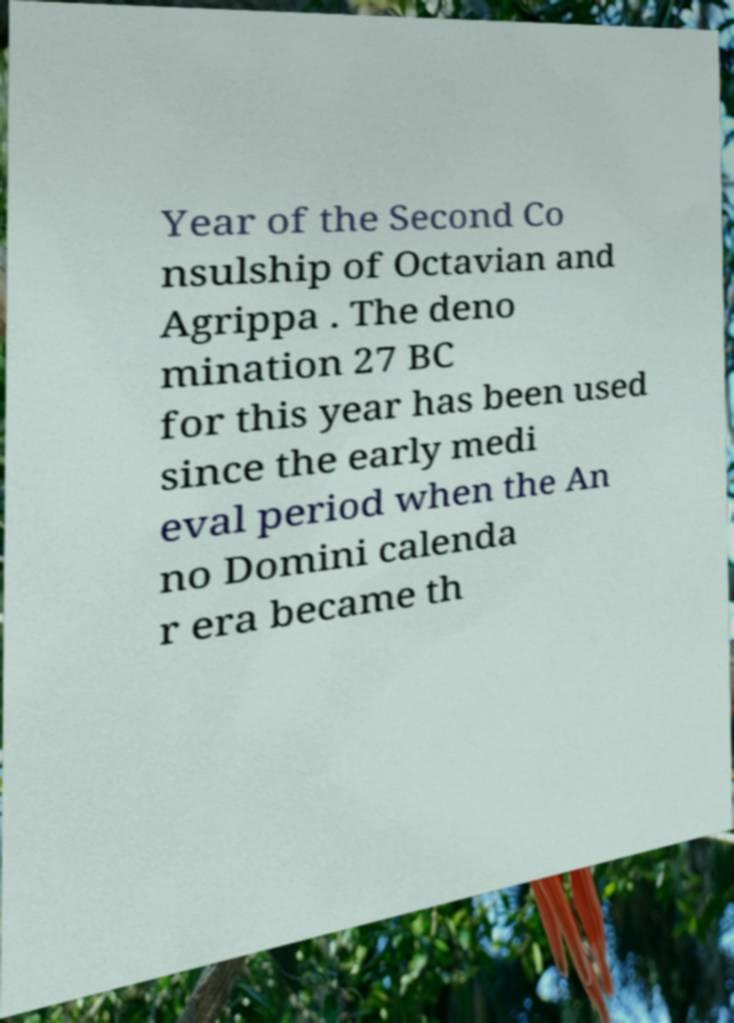Could you extract and type out the text from this image? Year of the Second Co nsulship of Octavian and Agrippa . The deno mination 27 BC for this year has been used since the early medi eval period when the An no Domini calenda r era became th 